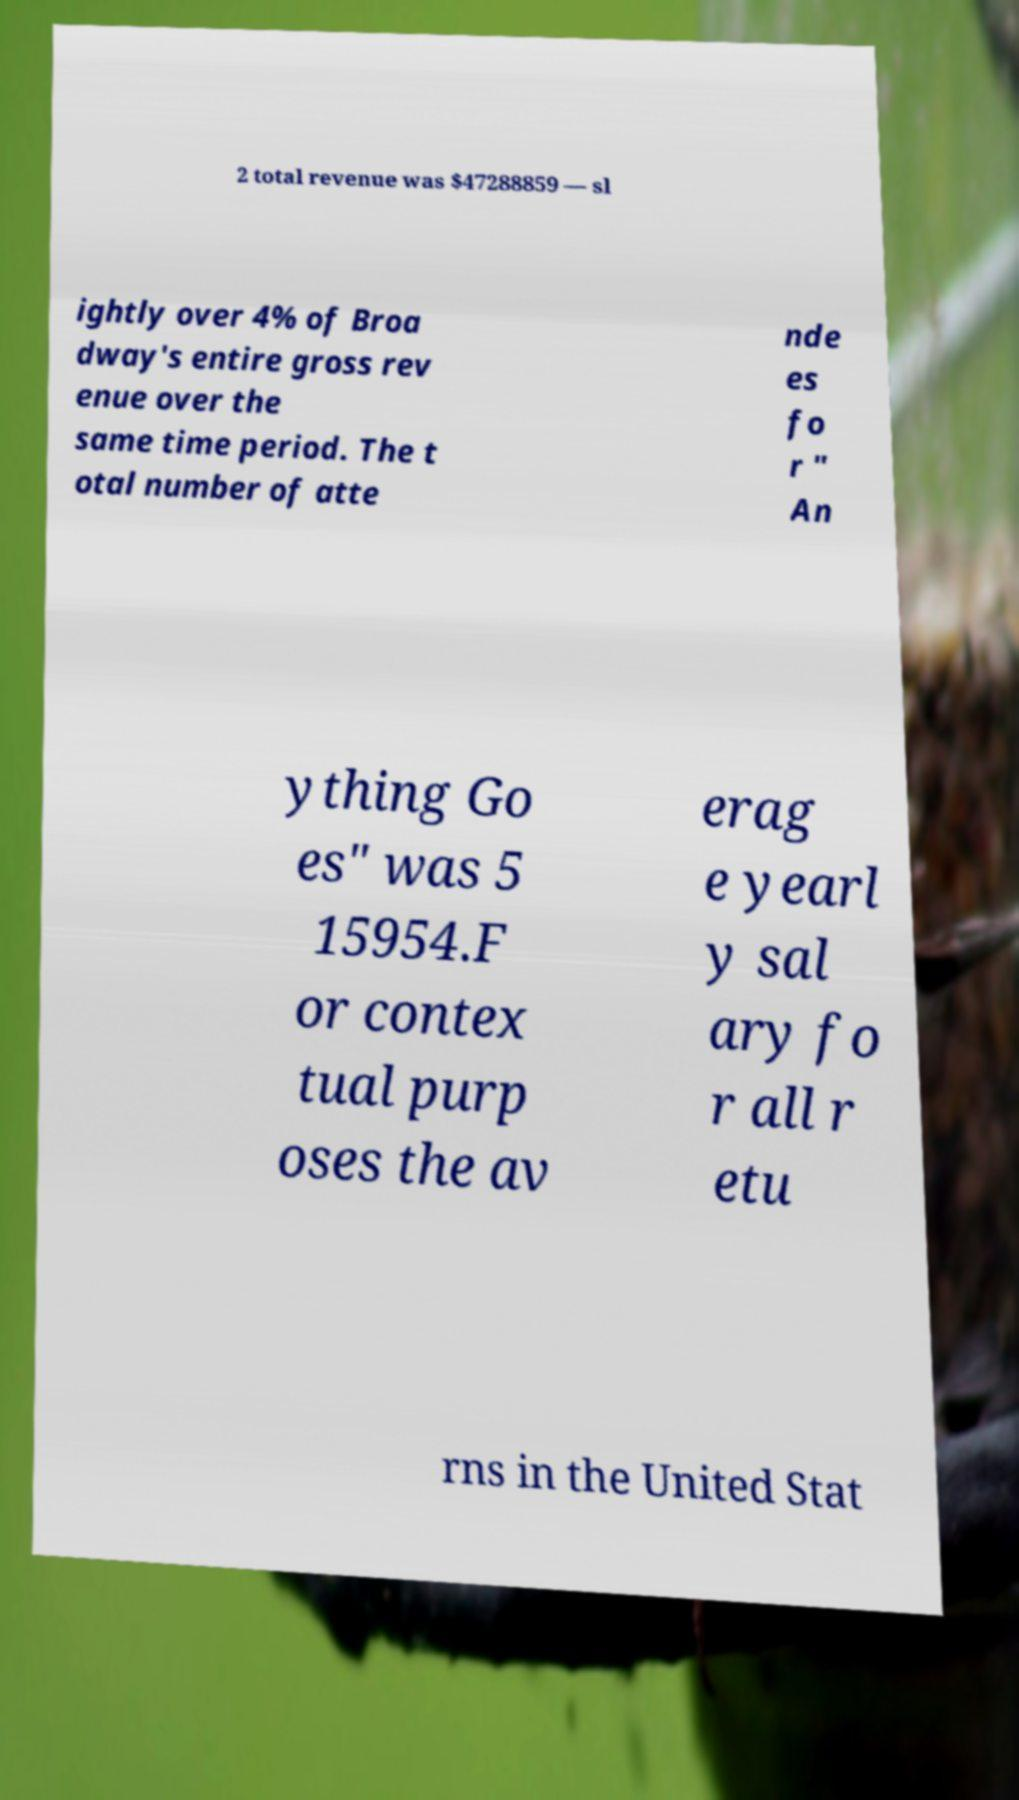There's text embedded in this image that I need extracted. Can you transcribe it verbatim? 2 total revenue was $47288859 — sl ightly over 4% of Broa dway's entire gross rev enue over the same time period. The t otal number of atte nde es fo r " An ything Go es" was 5 15954.F or contex tual purp oses the av erag e yearl y sal ary fo r all r etu rns in the United Stat 